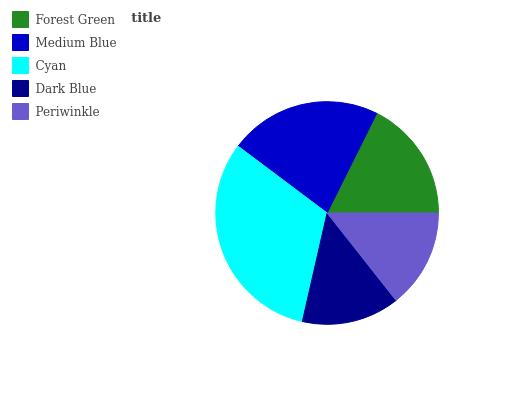Is Dark Blue the minimum?
Answer yes or no. Yes. Is Cyan the maximum?
Answer yes or no. Yes. Is Medium Blue the minimum?
Answer yes or no. No. Is Medium Blue the maximum?
Answer yes or no. No. Is Medium Blue greater than Forest Green?
Answer yes or no. Yes. Is Forest Green less than Medium Blue?
Answer yes or no. Yes. Is Forest Green greater than Medium Blue?
Answer yes or no. No. Is Medium Blue less than Forest Green?
Answer yes or no. No. Is Forest Green the high median?
Answer yes or no. Yes. Is Forest Green the low median?
Answer yes or no. Yes. Is Periwinkle the high median?
Answer yes or no. No. Is Dark Blue the low median?
Answer yes or no. No. 